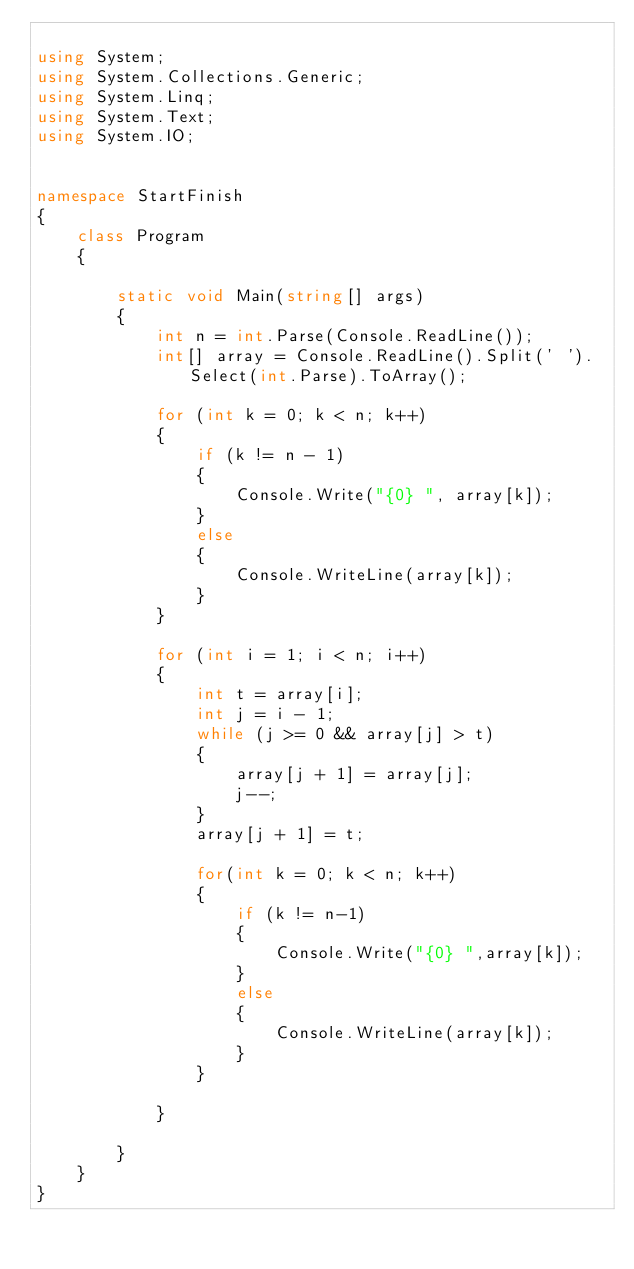Convert code to text. <code><loc_0><loc_0><loc_500><loc_500><_C#_>
using System;
using System.Collections.Generic;
using System.Linq;
using System.Text;
using System.IO;


namespace StartFinish
{
    class Program
    {
     
        static void Main(string[] args)
        {
            int n = int.Parse(Console.ReadLine());
            int[] array = Console.ReadLine().Split(' ').Select(int.Parse).ToArray();

            for (int k = 0; k < n; k++)
            {
                if (k != n - 1)
                {
                    Console.Write("{0} ", array[k]);
                }
                else
                {
                    Console.WriteLine(array[k]);
                }
            }

            for (int i = 1; i < n; i++)
            {
                int t = array[i];
                int j = i - 1;
                while (j >= 0 && array[j] > t)
                {
                    array[j + 1] = array[j];
                    j--;
                }
                array[j + 1] = t;
                
                for(int k = 0; k < n; k++)
                {
                    if (k != n-1)
                    {
                        Console.Write("{0} ",array[k]);
                    }
                    else
                    {
                        Console.WriteLine(array[k]);
                    }
                }

            }

        }
    }
}</code> 